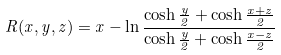Convert formula to latex. <formula><loc_0><loc_0><loc_500><loc_500>R ( x , y , z ) = x - \ln \frac { \cosh \frac { y } { 2 } + \cosh \frac { x + z } { 2 } } { \cosh \frac { y } { 2 } + \cosh \frac { x - z } { 2 } }</formula> 